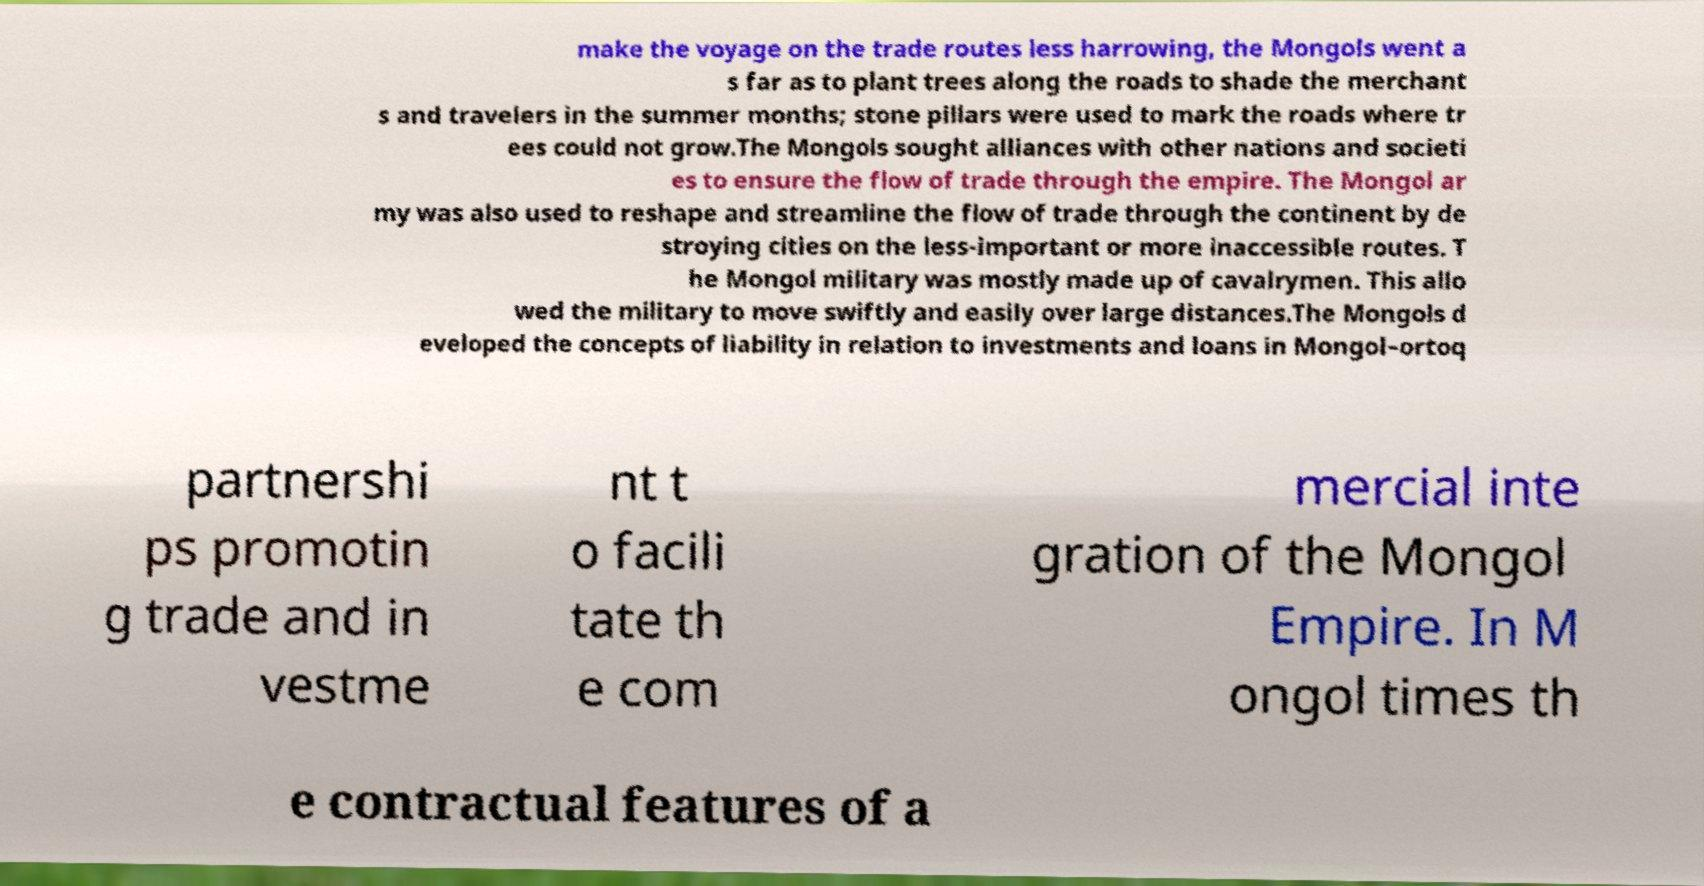Please read and relay the text visible in this image. What does it say? make the voyage on the trade routes less harrowing, the Mongols went a s far as to plant trees along the roads to shade the merchant s and travelers in the summer months; stone pillars were used to mark the roads where tr ees could not grow.The Mongols sought alliances with other nations and societi es to ensure the flow of trade through the empire. The Mongol ar my was also used to reshape and streamline the flow of trade through the continent by de stroying cities on the less-important or more inaccessible routes. T he Mongol military was mostly made up of cavalrymen. This allo wed the military to move swiftly and easily over large distances.The Mongols d eveloped the concepts of liability in relation to investments and loans in Mongol–ortoq partnershi ps promotin g trade and in vestme nt t o facili tate th e com mercial inte gration of the Mongol Empire. In M ongol times th e contractual features of a 